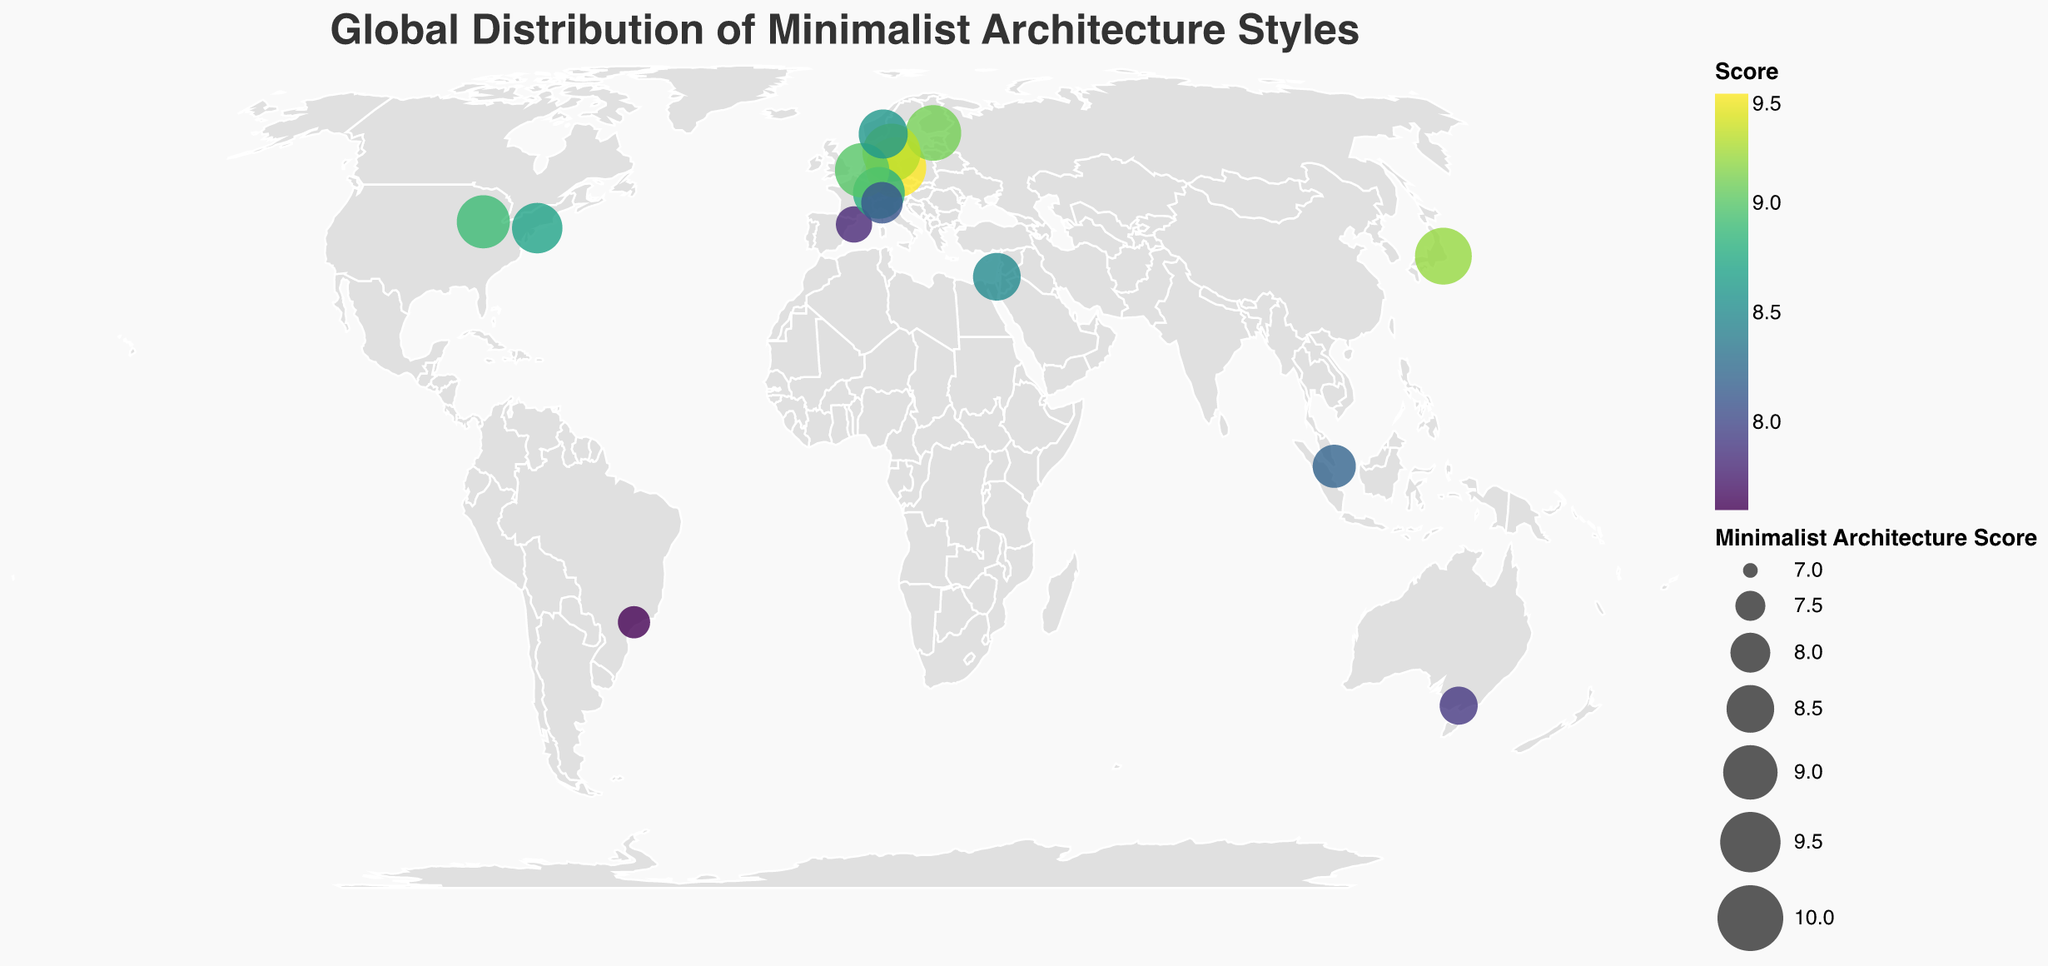What's the city with the highest Minimalist Architecture Score? By inspecting the size and color of the circles, the largest and darkest circle corresponds to Berlin, Germany, which has the highest score among all cities presented.
Answer: Berlin Which city in the USA has a higher Minimalist Architecture Score? The two cities in the USA are New York City and Chicago. Chicago has an 8.9 score, which is higher than New York City's 8.7 score.
Answer: Chicago What is the range of Minimalist Architecture Scores shown on the map? The highest score is 9.5 (Berlin) and the lowest score is 7.6 (São Paulo). The range is calculated as 9.5 - 7.6.
Answer: 1.9 How does Copenhagen's minimalism score compare to Zurich's? By looking at the color and size of the circles for Copenhagen and Zurich, Copenhagen (9.3) has a slightly higher score than Zurich (8.8).
Answer: Copenhagen has a higher score Which country in Europe has the city with the highest Minimalist Architecture Score? Inspect European cities: Berlin has the highest score at 9.5.
Answer: Germany What is the total count of cities displayed on the map? By counting each city's data point on the map, we see there are 15 cities.
Answer: 15 Which city in South America is included in the plot, and what's its score? The only South American city on the map is São Paulo, which has a score of 7.6.
Answer: São Paulo, 7.6 What continent has the highest representation of cities in this plot? By grouping cities per continent, Europe has the highest number of cities: Berlin, Barcelona, Helsinki, Copenhagen, Zurich, Rotterdam, Oslo, and Milan (8 cities).
Answer: Europe 